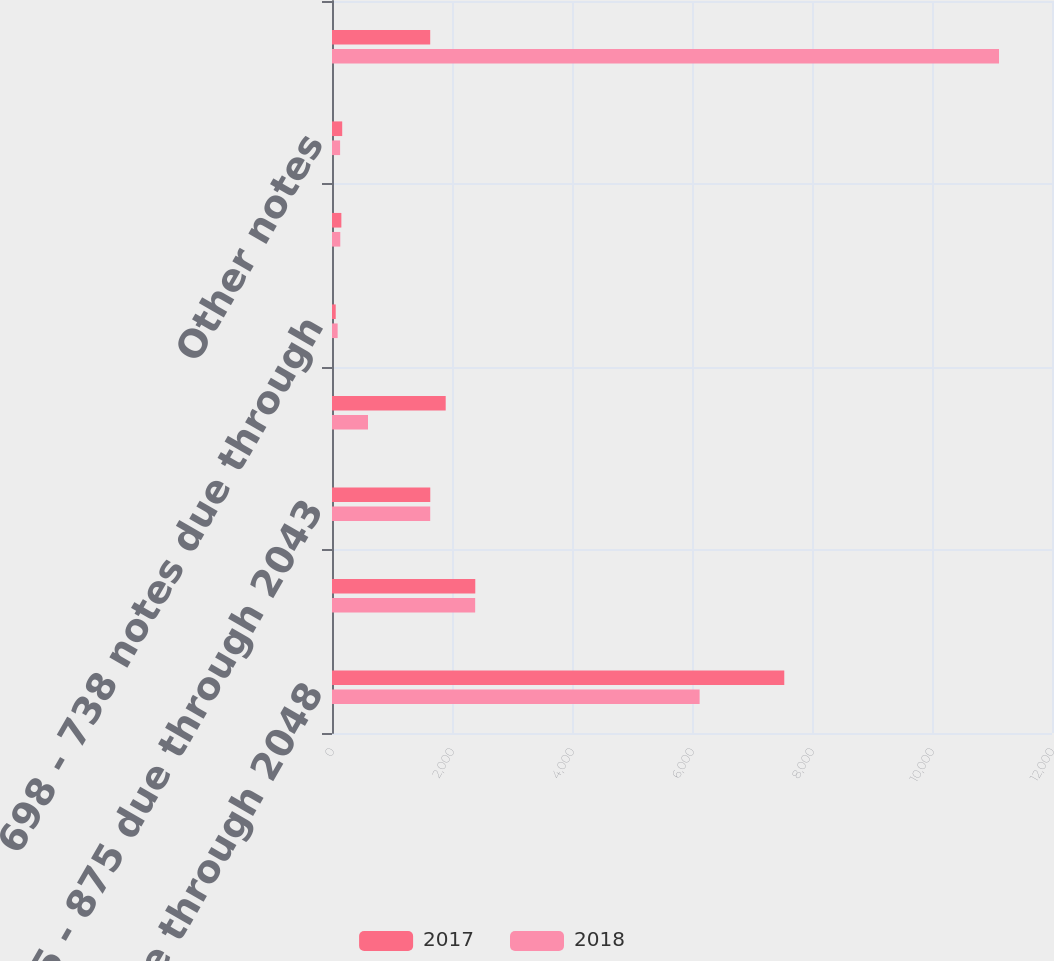Convert chart. <chart><loc_0><loc_0><loc_500><loc_500><stacked_bar_chart><ecel><fcel>095 - 488 due through 2048<fcel>580 - 688 due through 2043<fcel>725 - 875 due through 2043<fcel>Commercial paper<fcel>698 - 738 notes due through<fcel>Capital lease obligations due<fcel>Other notes<fcel>Total debt<nl><fcel>2017<fcel>7538<fcel>2388<fcel>1638<fcel>1895<fcel>62<fcel>156<fcel>170<fcel>1637<nl><fcel>2018<fcel>6127<fcel>2386<fcel>1637<fcel>600<fcel>94<fcel>138<fcel>135<fcel>11117<nl></chart> 